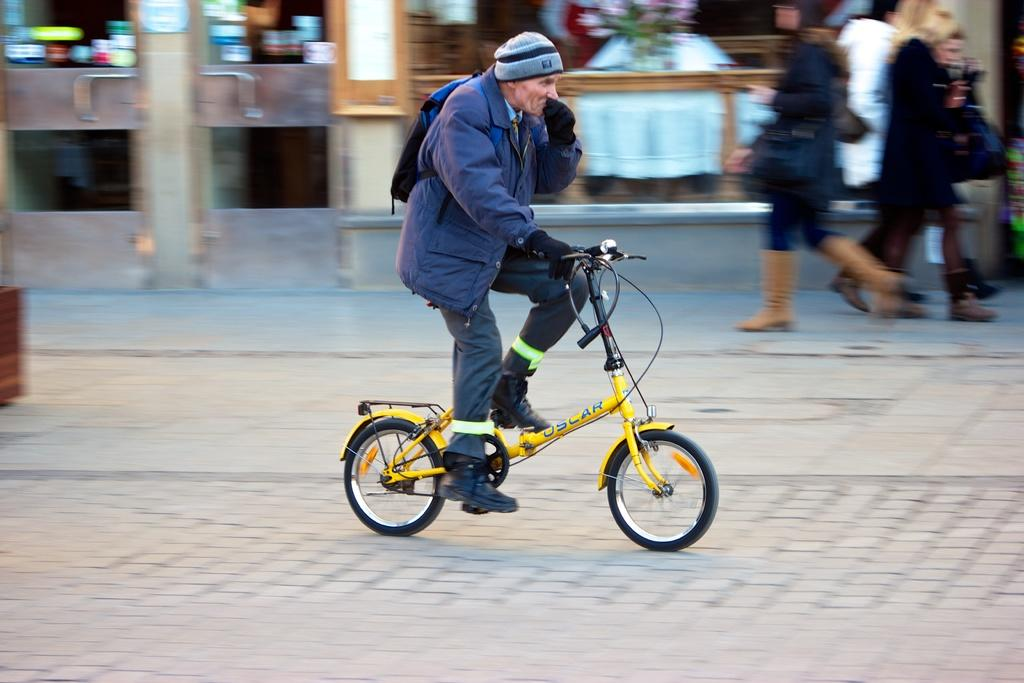Who is in the image? There is a man in the image. What is the man wearing? The man is wearing a blue jacket. What is the man doing in the image? The man is sitting on a cycle and riding on the road. What can be seen in the background of the image? There are people walking on the footpath, doors, and stores visible in the background. What type of verse can be heard being recited by the man in the image? There is no indication in the image that the man is reciting a verse, so it cannot be determined from the picture. 